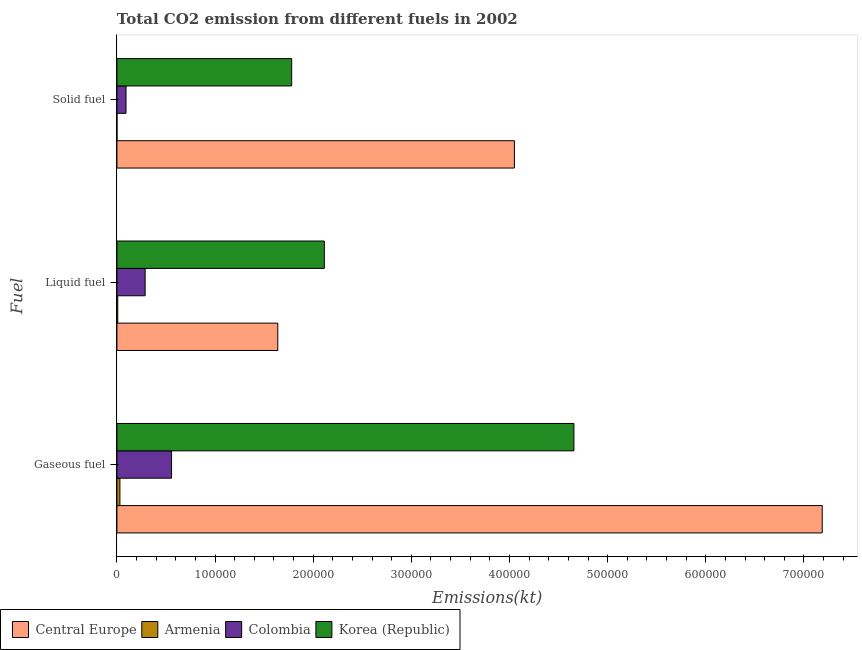How many different coloured bars are there?
Your answer should be compact. 4. How many groups of bars are there?
Your answer should be compact. 3. Are the number of bars on each tick of the Y-axis equal?
Ensure brevity in your answer.  Yes. How many bars are there on the 2nd tick from the bottom?
Make the answer very short. 4. What is the label of the 2nd group of bars from the top?
Give a very brief answer. Liquid fuel. What is the amount of co2 emissions from gaseous fuel in Armenia?
Your answer should be compact. 3043.61. Across all countries, what is the maximum amount of co2 emissions from gaseous fuel?
Provide a succinct answer. 7.19e+05. Across all countries, what is the minimum amount of co2 emissions from solid fuel?
Make the answer very short. 47.67. In which country was the amount of co2 emissions from solid fuel maximum?
Your response must be concise. Central Europe. In which country was the amount of co2 emissions from solid fuel minimum?
Your answer should be very brief. Armenia. What is the total amount of co2 emissions from liquid fuel in the graph?
Ensure brevity in your answer.  4.05e+05. What is the difference between the amount of co2 emissions from liquid fuel in Armenia and that in Central Europe?
Your answer should be compact. -1.63e+05. What is the difference between the amount of co2 emissions from gaseous fuel in Korea (Republic) and the amount of co2 emissions from liquid fuel in Colombia?
Make the answer very short. 4.37e+05. What is the average amount of co2 emissions from liquid fuel per country?
Provide a short and direct response. 1.01e+05. What is the difference between the amount of co2 emissions from liquid fuel and amount of co2 emissions from solid fuel in Colombia?
Provide a succinct answer. 1.95e+04. What is the ratio of the amount of co2 emissions from solid fuel in Korea (Republic) to that in Armenia?
Make the answer very short. 3734.85. Is the amount of co2 emissions from gaseous fuel in Armenia less than that in Colombia?
Offer a very short reply. Yes. Is the difference between the amount of co2 emissions from liquid fuel in Korea (Republic) and Armenia greater than the difference between the amount of co2 emissions from solid fuel in Korea (Republic) and Armenia?
Provide a short and direct response. Yes. What is the difference between the highest and the second highest amount of co2 emissions from liquid fuel?
Make the answer very short. 4.74e+04. What is the difference between the highest and the lowest amount of co2 emissions from solid fuel?
Give a very brief answer. 4.05e+05. Is the sum of the amount of co2 emissions from gaseous fuel in Colombia and Armenia greater than the maximum amount of co2 emissions from solid fuel across all countries?
Your answer should be compact. No. What does the 2nd bar from the top in Liquid fuel represents?
Provide a succinct answer. Colombia. What does the 2nd bar from the bottom in Solid fuel represents?
Your answer should be compact. Armenia. Is it the case that in every country, the sum of the amount of co2 emissions from gaseous fuel and amount of co2 emissions from liquid fuel is greater than the amount of co2 emissions from solid fuel?
Provide a short and direct response. Yes. Are all the bars in the graph horizontal?
Your answer should be compact. Yes. How many countries are there in the graph?
Your response must be concise. 4. What is the difference between two consecutive major ticks on the X-axis?
Provide a succinct answer. 1.00e+05. Does the graph contain any zero values?
Give a very brief answer. No. Does the graph contain grids?
Ensure brevity in your answer.  No. What is the title of the graph?
Make the answer very short. Total CO2 emission from different fuels in 2002. What is the label or title of the X-axis?
Your answer should be compact. Emissions(kt). What is the label or title of the Y-axis?
Make the answer very short. Fuel. What is the Emissions(kt) of Central Europe in Gaseous fuel?
Provide a short and direct response. 7.19e+05. What is the Emissions(kt) in Armenia in Gaseous fuel?
Offer a terse response. 3043.61. What is the Emissions(kt) of Colombia in Gaseous fuel?
Provide a short and direct response. 5.57e+04. What is the Emissions(kt) of Korea (Republic) in Gaseous fuel?
Make the answer very short. 4.66e+05. What is the Emissions(kt) in Central Europe in Liquid fuel?
Make the answer very short. 1.64e+05. What is the Emissions(kt) of Armenia in Liquid fuel?
Offer a terse response. 817.74. What is the Emissions(kt) in Colombia in Liquid fuel?
Make the answer very short. 2.87e+04. What is the Emissions(kt) of Korea (Republic) in Liquid fuel?
Your answer should be compact. 2.11e+05. What is the Emissions(kt) in Central Europe in Solid fuel?
Give a very brief answer. 4.05e+05. What is the Emissions(kt) in Armenia in Solid fuel?
Make the answer very short. 47.67. What is the Emissions(kt) of Colombia in Solid fuel?
Give a very brief answer. 9273.84. What is the Emissions(kt) of Korea (Republic) in Solid fuel?
Provide a succinct answer. 1.78e+05. Across all Fuel, what is the maximum Emissions(kt) in Central Europe?
Your answer should be very brief. 7.19e+05. Across all Fuel, what is the maximum Emissions(kt) of Armenia?
Provide a short and direct response. 3043.61. Across all Fuel, what is the maximum Emissions(kt) of Colombia?
Keep it short and to the point. 5.57e+04. Across all Fuel, what is the maximum Emissions(kt) of Korea (Republic)?
Your answer should be very brief. 4.66e+05. Across all Fuel, what is the minimum Emissions(kt) in Central Europe?
Your answer should be compact. 1.64e+05. Across all Fuel, what is the minimum Emissions(kt) in Armenia?
Ensure brevity in your answer.  47.67. Across all Fuel, what is the minimum Emissions(kt) of Colombia?
Give a very brief answer. 9273.84. Across all Fuel, what is the minimum Emissions(kt) of Korea (Republic)?
Offer a terse response. 1.78e+05. What is the total Emissions(kt) in Central Europe in the graph?
Make the answer very short. 1.29e+06. What is the total Emissions(kt) in Armenia in the graph?
Your answer should be compact. 3909.02. What is the total Emissions(kt) of Colombia in the graph?
Provide a short and direct response. 9.37e+04. What is the total Emissions(kt) in Korea (Republic) in the graph?
Offer a terse response. 8.55e+05. What is the difference between the Emissions(kt) of Central Europe in Gaseous fuel and that in Liquid fuel?
Ensure brevity in your answer.  5.55e+05. What is the difference between the Emissions(kt) in Armenia in Gaseous fuel and that in Liquid fuel?
Offer a terse response. 2225.87. What is the difference between the Emissions(kt) in Colombia in Gaseous fuel and that in Liquid fuel?
Your response must be concise. 2.69e+04. What is the difference between the Emissions(kt) in Korea (Republic) in Gaseous fuel and that in Liquid fuel?
Keep it short and to the point. 2.54e+05. What is the difference between the Emissions(kt) in Central Europe in Gaseous fuel and that in Solid fuel?
Provide a short and direct response. 3.14e+05. What is the difference between the Emissions(kt) of Armenia in Gaseous fuel and that in Solid fuel?
Ensure brevity in your answer.  2995.94. What is the difference between the Emissions(kt) in Colombia in Gaseous fuel and that in Solid fuel?
Your response must be concise. 4.64e+04. What is the difference between the Emissions(kt) of Korea (Republic) in Gaseous fuel and that in Solid fuel?
Your response must be concise. 2.88e+05. What is the difference between the Emissions(kt) of Central Europe in Liquid fuel and that in Solid fuel?
Make the answer very short. -2.41e+05. What is the difference between the Emissions(kt) of Armenia in Liquid fuel and that in Solid fuel?
Offer a very short reply. 770.07. What is the difference between the Emissions(kt) of Colombia in Liquid fuel and that in Solid fuel?
Your answer should be compact. 1.95e+04. What is the difference between the Emissions(kt) in Korea (Republic) in Liquid fuel and that in Solid fuel?
Offer a terse response. 3.33e+04. What is the difference between the Emissions(kt) of Central Europe in Gaseous fuel and the Emissions(kt) of Armenia in Liquid fuel?
Provide a short and direct response. 7.18e+05. What is the difference between the Emissions(kt) in Central Europe in Gaseous fuel and the Emissions(kt) in Colombia in Liquid fuel?
Your answer should be very brief. 6.90e+05. What is the difference between the Emissions(kt) of Central Europe in Gaseous fuel and the Emissions(kt) of Korea (Republic) in Liquid fuel?
Your response must be concise. 5.07e+05. What is the difference between the Emissions(kt) of Armenia in Gaseous fuel and the Emissions(kt) of Colombia in Liquid fuel?
Offer a terse response. -2.57e+04. What is the difference between the Emissions(kt) in Armenia in Gaseous fuel and the Emissions(kt) in Korea (Republic) in Liquid fuel?
Offer a very short reply. -2.08e+05. What is the difference between the Emissions(kt) of Colombia in Gaseous fuel and the Emissions(kt) of Korea (Republic) in Liquid fuel?
Make the answer very short. -1.56e+05. What is the difference between the Emissions(kt) in Central Europe in Gaseous fuel and the Emissions(kt) in Armenia in Solid fuel?
Make the answer very short. 7.19e+05. What is the difference between the Emissions(kt) of Central Europe in Gaseous fuel and the Emissions(kt) of Colombia in Solid fuel?
Give a very brief answer. 7.09e+05. What is the difference between the Emissions(kt) in Central Europe in Gaseous fuel and the Emissions(kt) in Korea (Republic) in Solid fuel?
Ensure brevity in your answer.  5.41e+05. What is the difference between the Emissions(kt) of Armenia in Gaseous fuel and the Emissions(kt) of Colombia in Solid fuel?
Give a very brief answer. -6230.23. What is the difference between the Emissions(kt) of Armenia in Gaseous fuel and the Emissions(kt) of Korea (Republic) in Solid fuel?
Provide a short and direct response. -1.75e+05. What is the difference between the Emissions(kt) of Colombia in Gaseous fuel and the Emissions(kt) of Korea (Republic) in Solid fuel?
Make the answer very short. -1.22e+05. What is the difference between the Emissions(kt) of Central Europe in Liquid fuel and the Emissions(kt) of Armenia in Solid fuel?
Offer a terse response. 1.64e+05. What is the difference between the Emissions(kt) of Central Europe in Liquid fuel and the Emissions(kt) of Colombia in Solid fuel?
Your response must be concise. 1.55e+05. What is the difference between the Emissions(kt) of Central Europe in Liquid fuel and the Emissions(kt) of Korea (Republic) in Solid fuel?
Provide a short and direct response. -1.41e+04. What is the difference between the Emissions(kt) in Armenia in Liquid fuel and the Emissions(kt) in Colombia in Solid fuel?
Provide a short and direct response. -8456.1. What is the difference between the Emissions(kt) in Armenia in Liquid fuel and the Emissions(kt) in Korea (Republic) in Solid fuel?
Keep it short and to the point. -1.77e+05. What is the difference between the Emissions(kt) in Colombia in Liquid fuel and the Emissions(kt) in Korea (Republic) in Solid fuel?
Make the answer very short. -1.49e+05. What is the average Emissions(kt) of Central Europe per Fuel?
Provide a succinct answer. 4.29e+05. What is the average Emissions(kt) of Armenia per Fuel?
Your answer should be very brief. 1303.01. What is the average Emissions(kt) in Colombia per Fuel?
Your answer should be very brief. 3.12e+04. What is the average Emissions(kt) in Korea (Republic) per Fuel?
Give a very brief answer. 2.85e+05. What is the difference between the Emissions(kt) of Central Europe and Emissions(kt) of Armenia in Gaseous fuel?
Your answer should be very brief. 7.16e+05. What is the difference between the Emissions(kt) of Central Europe and Emissions(kt) of Colombia in Gaseous fuel?
Offer a terse response. 6.63e+05. What is the difference between the Emissions(kt) of Central Europe and Emissions(kt) of Korea (Republic) in Gaseous fuel?
Your answer should be compact. 2.53e+05. What is the difference between the Emissions(kt) of Armenia and Emissions(kt) of Colombia in Gaseous fuel?
Provide a short and direct response. -5.26e+04. What is the difference between the Emissions(kt) of Armenia and Emissions(kt) of Korea (Republic) in Gaseous fuel?
Give a very brief answer. -4.63e+05. What is the difference between the Emissions(kt) in Colombia and Emissions(kt) in Korea (Republic) in Gaseous fuel?
Provide a succinct answer. -4.10e+05. What is the difference between the Emissions(kt) in Central Europe and Emissions(kt) in Armenia in Liquid fuel?
Give a very brief answer. 1.63e+05. What is the difference between the Emissions(kt) of Central Europe and Emissions(kt) of Colombia in Liquid fuel?
Keep it short and to the point. 1.35e+05. What is the difference between the Emissions(kt) of Central Europe and Emissions(kt) of Korea (Republic) in Liquid fuel?
Keep it short and to the point. -4.74e+04. What is the difference between the Emissions(kt) of Armenia and Emissions(kt) of Colombia in Liquid fuel?
Make the answer very short. -2.79e+04. What is the difference between the Emissions(kt) in Armenia and Emissions(kt) in Korea (Republic) in Liquid fuel?
Offer a very short reply. -2.11e+05. What is the difference between the Emissions(kt) of Colombia and Emissions(kt) of Korea (Republic) in Liquid fuel?
Ensure brevity in your answer.  -1.83e+05. What is the difference between the Emissions(kt) in Central Europe and Emissions(kt) in Armenia in Solid fuel?
Your answer should be very brief. 4.05e+05. What is the difference between the Emissions(kt) of Central Europe and Emissions(kt) of Colombia in Solid fuel?
Your answer should be very brief. 3.96e+05. What is the difference between the Emissions(kt) in Central Europe and Emissions(kt) in Korea (Republic) in Solid fuel?
Ensure brevity in your answer.  2.27e+05. What is the difference between the Emissions(kt) in Armenia and Emissions(kt) in Colombia in Solid fuel?
Offer a very short reply. -9226.17. What is the difference between the Emissions(kt) in Armenia and Emissions(kt) in Korea (Republic) in Solid fuel?
Keep it short and to the point. -1.78e+05. What is the difference between the Emissions(kt) in Colombia and Emissions(kt) in Korea (Republic) in Solid fuel?
Offer a very short reply. -1.69e+05. What is the ratio of the Emissions(kt) in Central Europe in Gaseous fuel to that in Liquid fuel?
Your answer should be compact. 4.38. What is the ratio of the Emissions(kt) of Armenia in Gaseous fuel to that in Liquid fuel?
Your answer should be very brief. 3.72. What is the ratio of the Emissions(kt) in Colombia in Gaseous fuel to that in Liquid fuel?
Keep it short and to the point. 1.94. What is the ratio of the Emissions(kt) in Korea (Republic) in Gaseous fuel to that in Liquid fuel?
Ensure brevity in your answer.  2.2. What is the ratio of the Emissions(kt) in Central Europe in Gaseous fuel to that in Solid fuel?
Your response must be concise. 1.77. What is the ratio of the Emissions(kt) of Armenia in Gaseous fuel to that in Solid fuel?
Your answer should be compact. 63.85. What is the ratio of the Emissions(kt) in Colombia in Gaseous fuel to that in Solid fuel?
Offer a very short reply. 6. What is the ratio of the Emissions(kt) in Korea (Republic) in Gaseous fuel to that in Solid fuel?
Your answer should be compact. 2.62. What is the ratio of the Emissions(kt) in Central Europe in Liquid fuel to that in Solid fuel?
Offer a very short reply. 0.4. What is the ratio of the Emissions(kt) of Armenia in Liquid fuel to that in Solid fuel?
Your answer should be compact. 17.15. What is the ratio of the Emissions(kt) in Colombia in Liquid fuel to that in Solid fuel?
Ensure brevity in your answer.  3.1. What is the ratio of the Emissions(kt) in Korea (Republic) in Liquid fuel to that in Solid fuel?
Offer a very short reply. 1.19. What is the difference between the highest and the second highest Emissions(kt) of Central Europe?
Make the answer very short. 3.14e+05. What is the difference between the highest and the second highest Emissions(kt) of Armenia?
Provide a succinct answer. 2225.87. What is the difference between the highest and the second highest Emissions(kt) of Colombia?
Your answer should be compact. 2.69e+04. What is the difference between the highest and the second highest Emissions(kt) in Korea (Republic)?
Your response must be concise. 2.54e+05. What is the difference between the highest and the lowest Emissions(kt) of Central Europe?
Provide a short and direct response. 5.55e+05. What is the difference between the highest and the lowest Emissions(kt) of Armenia?
Keep it short and to the point. 2995.94. What is the difference between the highest and the lowest Emissions(kt) in Colombia?
Provide a short and direct response. 4.64e+04. What is the difference between the highest and the lowest Emissions(kt) in Korea (Republic)?
Provide a short and direct response. 2.88e+05. 